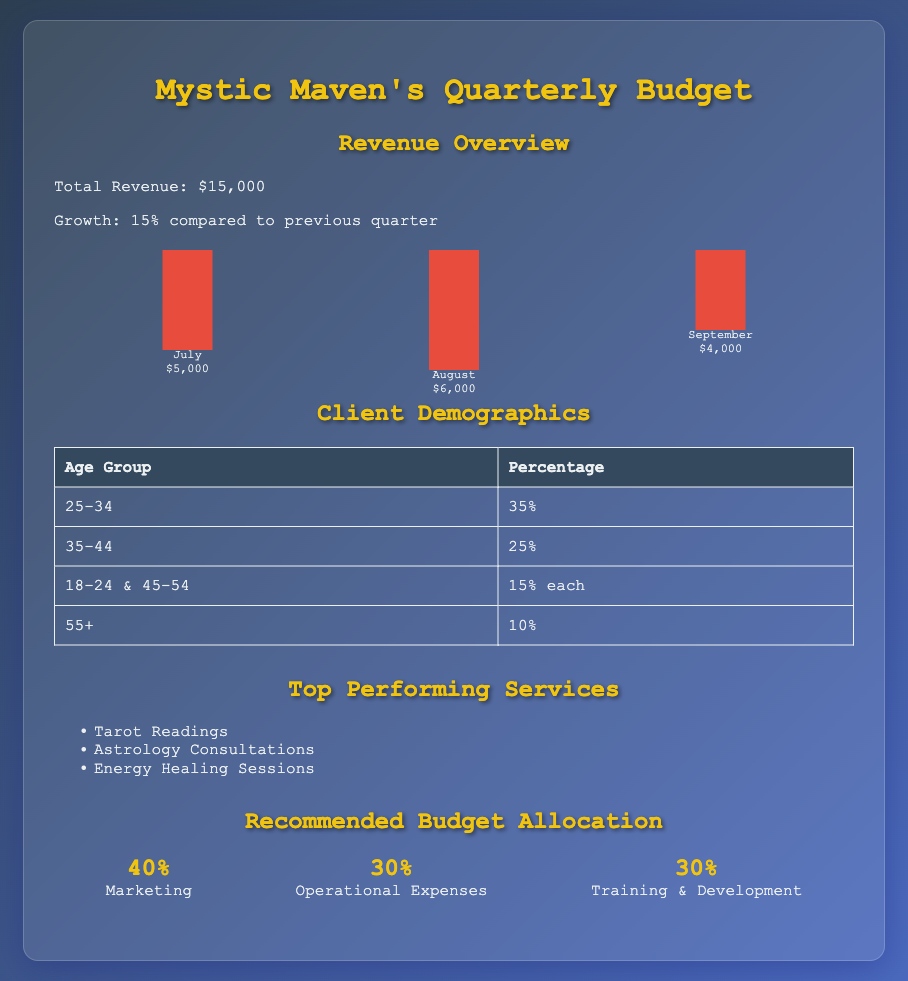What was the total revenue for the quarter? The total revenue is clearly stated in the document as $15,000.
Answer: $15,000 Which month had the highest revenue? The document shows the monthly revenues, with August generating the most revenue at $6,000.
Answer: August What age group constitutes the largest percentage of clients? The client demographics table indicates that the age group 25-34 represents the largest percentage at 35%.
Answer: 25-34 What percentage of the budget is allocated for marketing? The recommended budget allocation section specifies that 40% of the budget is earmarked for marketing.
Answer: 40% How much did revenue grow compared to the previous quarter? The revenue growth percentage is indicated as 15% in the revenue overview section.
Answer: 15% Which service is listed as a top performer? The top performing services section lists several, with Tarot Readings highlighted as one of them.
Answer: Tarot Readings What is the total percentage of clients aged 55 and above? The document shows that 10% of clients are aged 55+, resulting in a total of 10% for that demographic.
Answer: 10% What portion of the budget is allocated for operational expenses? According to the budget allocation, operational expenses account for 30% of the total budget.
Answer: 30% 